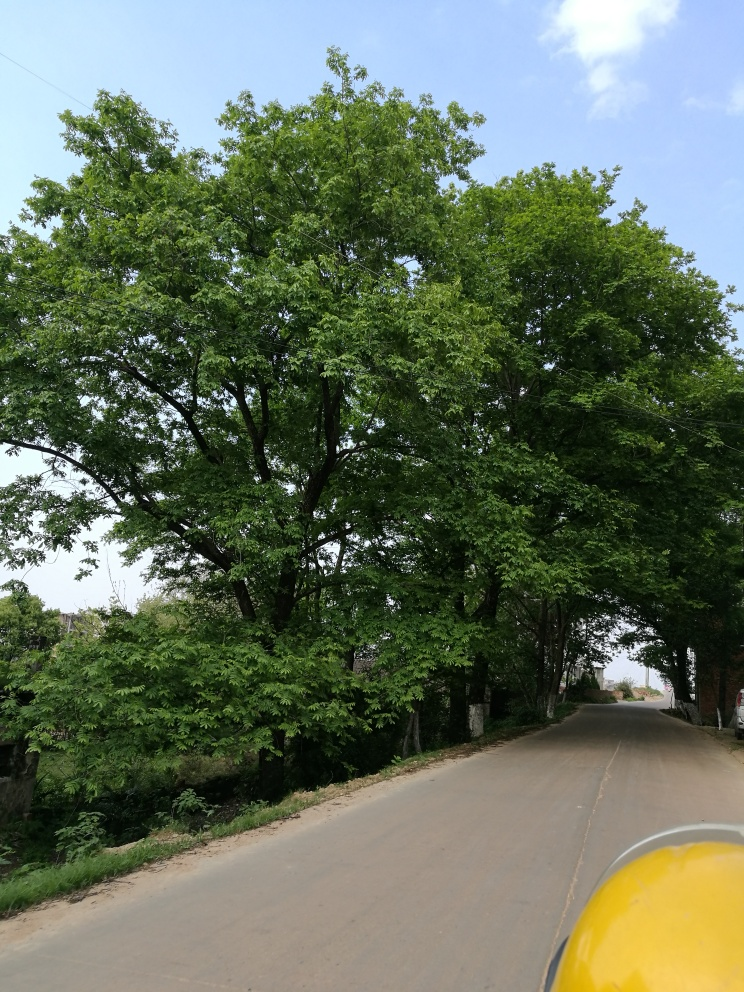Can you tell me about the types of trees in this image? The image features deciduous trees, likely in the midst of spring or summer given their lush green foliage. Without closer inspection or knowledge of the local flora, it's difficult to determine the specific species, but they seem to be well-established, mature trees lining the road. 